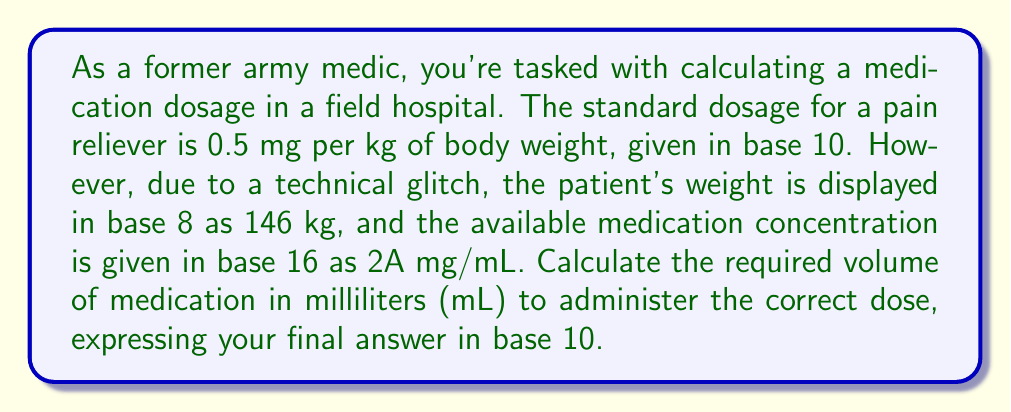What is the answer to this math problem? To solve this problem, we need to follow these steps:

1. Convert the patient's weight from base 8 to base 10:
   $146_8 = 1 \times 8^2 + 4 \times 8^1 + 6 \times 8^0 = 64 + 32 + 6 = 102_{10}$ kg

2. Convert the medication concentration from base 16 to base 10:
   $2A_{16} = 2 \times 16^1 + 10 \times 16^0 = 32 + 10 = 42_{10}$ mg/mL

3. Calculate the required dose based on the patient's weight:
   Dose = $0.5 \text{ mg/kg} \times 102 \text{ kg} = 51 \text{ mg}$

4. Set up a proportion to determine the volume needed:
   $$\frac{42 \text{ mg}}{1 \text{ mL}} = \frac{51 \text{ mg}}{x \text{ mL}}$$

5. Solve for x:
   $$x = \frac{51 \text{ mg} \times 1 \text{ mL}}{42 \text{ mg}} = 1.2142857... \text{ mL}$$

6. Round to a practical volume for administration:
   $1.21 \text{ mL}$ (rounded to two decimal places)
Answer: $1.21 \text{ mL}$ 